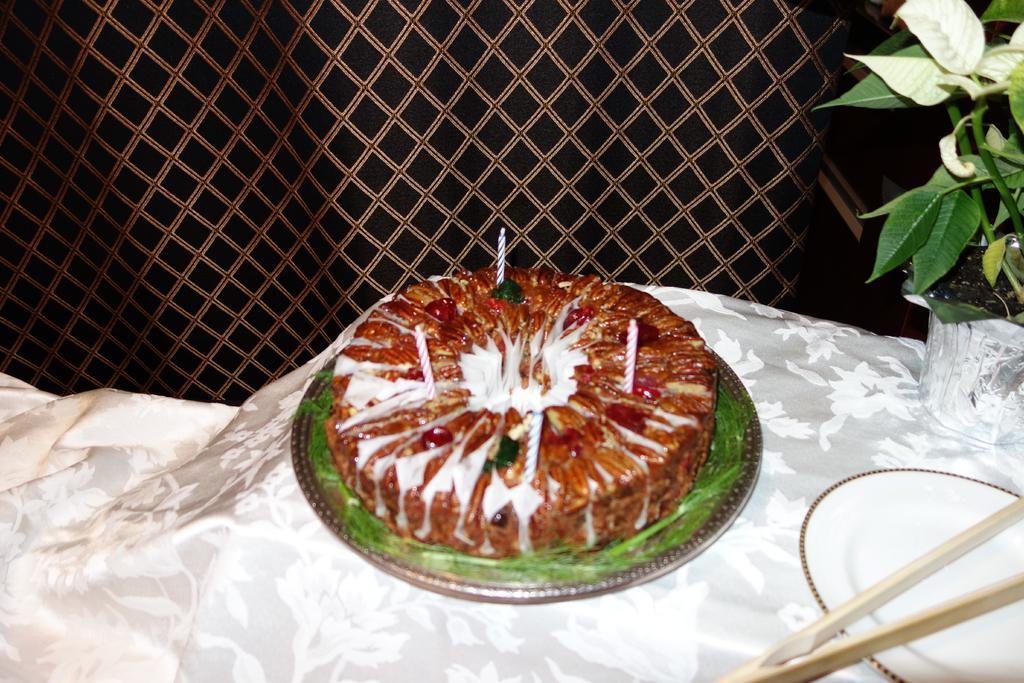In one or two sentences, can you explain what this image depicts? In this image I can see a cake,plate and a flower pot. 